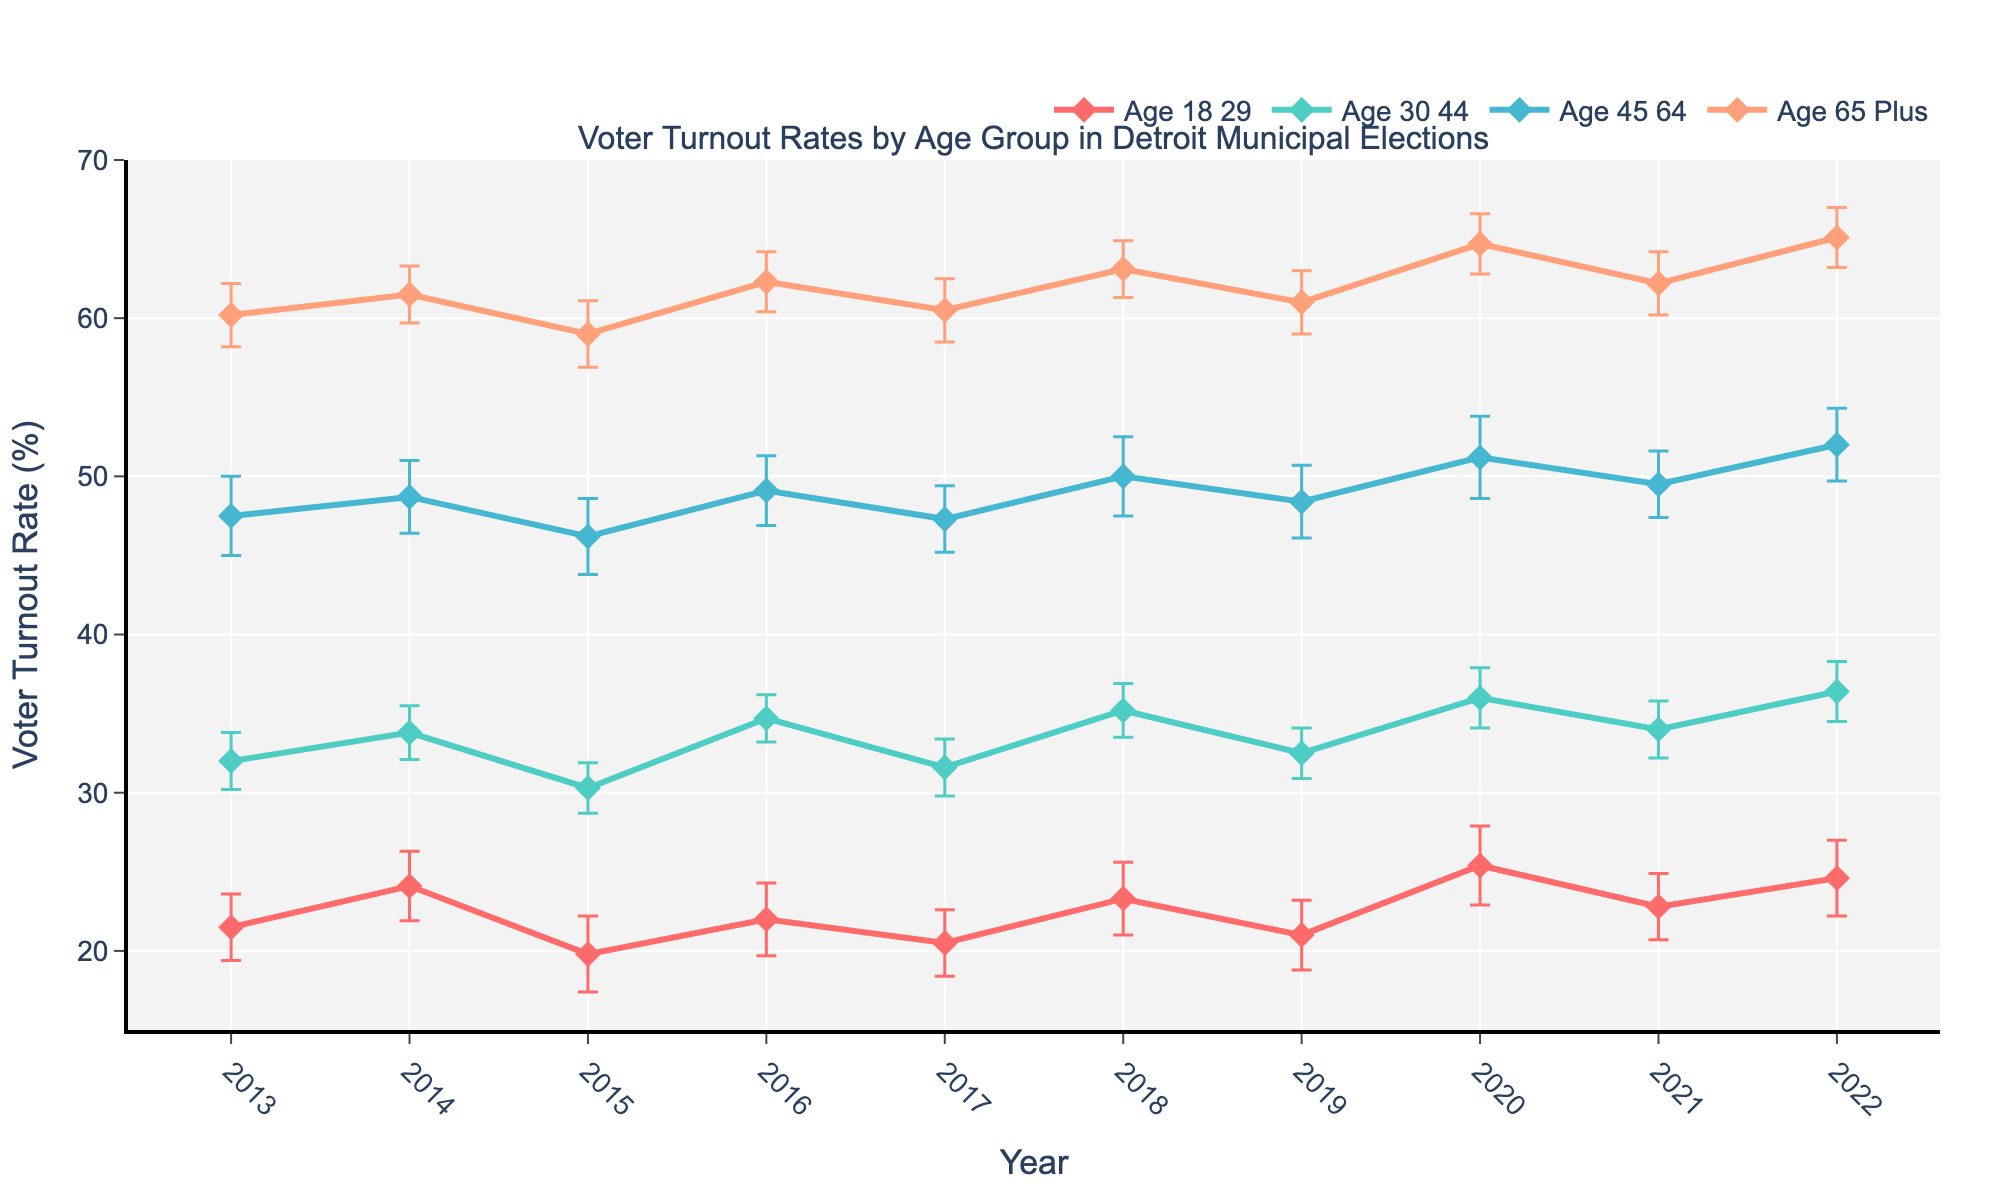What's the title of the figure? The title can be observed at the top of the figure. It reads "Voter Turnout Rates by Age Group in Detroit Municipal Elections".
Answer: Voter Turnout Rates by Age Group in Detroit Municipal Elections How many age groups are being tracked in the figure? The number of lines and age group names in the legend indicate that there are four age groups. These are Age 18-29, Age 30-44, Age 45-64, and Age 65 Plus.
Answer: Four What color represents the age group 65 Plus? Each age group is represented by a different color line. The age group 65 Plus is represented by the color orange.
Answer: Orange In which year did the age group 18-29 have the lowest voter turnout, and what was the turnout rate? By looking along the line for Age 18-29, the lowest point is in the year 2015 with a turnout rate of 19.8%.
Answer: 2015, 19.8% What is the general trend in the voter turnout rates for the age group 30-44 between 2013 to 2022? The line for Age 30-44 shows an upward trend from 2013 to 2022. This indicates that voter turnout rates for this age group generally increased over this period.
Answer: Increasing Compare the voter turnout rates of Age 45-64 and Age 65 Plus in 2020. Which age group had a higher turnout, and by how much? The value for Age 45-64 in 2020 is 51.2%, and for Age 65 Plus, it is 64.7%. Subtracting the former from the latter gives us the difference.
Answer: Age 65 Plus, 13.5% What was the voter turnout rate for the age group 18-29 in 2016 including the error range? The voter turnout rate for Age 18-29 in 2016 is 22.0% with an error of ±2.3%. Therefore, the range is from 22.0% - 2.3% to 22.0% + 2.3%, which is 19.7% to 24.3%.
Answer: 19.7% to 24.3% Which age group had the most variation in voter turnout rates over the ten years based on visual observation? The age group with the most fluctuating line in the plot is Age 18-29, indicating the most variation in voter turnout over the ten years.
Answer: Age 18-29 In which year did the age group 65 Plus have the highest voter turnout, and what was the turnout rate? The highest point on the line representing Age 65 Plus is in 2022, with a turnout rate of 65.1%.
Answer: 2022, 65.1% 